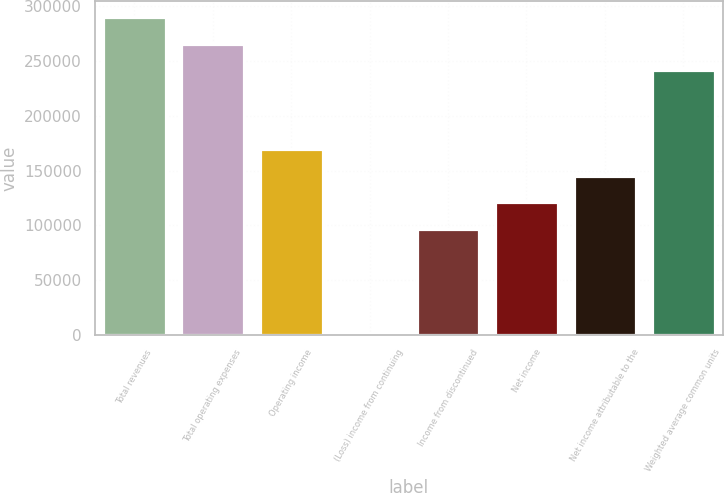Convert chart. <chart><loc_0><loc_0><loc_500><loc_500><bar_chart><fcel>Total revenues<fcel>Total operating expenses<fcel>Operating income<fcel>(Loss) income from continuing<fcel>Income from discontinued<fcel>Net income<fcel>Net income attributable to the<fcel>Weighted average common units<nl><fcel>290093<fcel>265918<fcel>169221<fcel>0.01<fcel>96697.6<fcel>120872<fcel>145046<fcel>241744<nl></chart> 